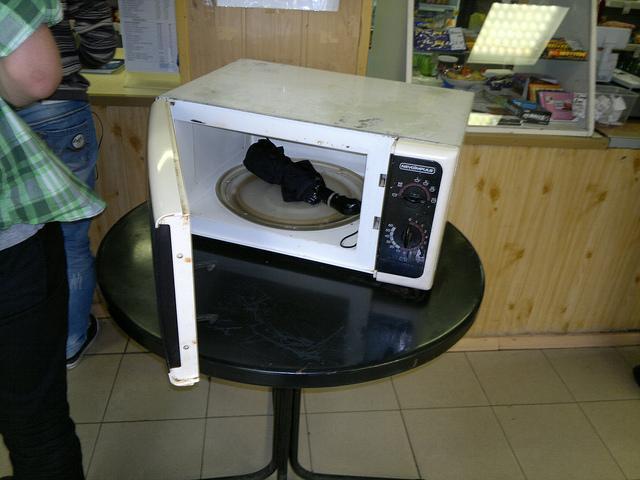Inside what is the umbrella?
Pick the right solution, then justify: 'Answer: answer
Rationale: rationale.'
Options: Toaster, microwave, umbrella stand, dishwasher. Answer: microwave.
Rationale: You can tell by the shape of the appliance to where the umbrella is in. 